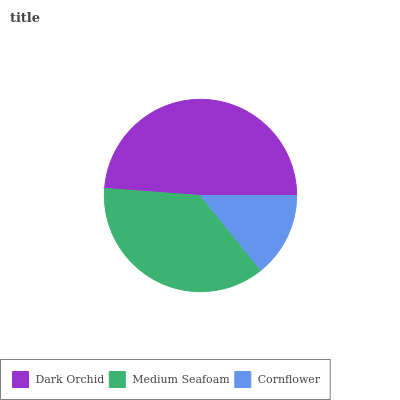Is Cornflower the minimum?
Answer yes or no. Yes. Is Dark Orchid the maximum?
Answer yes or no. Yes. Is Medium Seafoam the minimum?
Answer yes or no. No. Is Medium Seafoam the maximum?
Answer yes or no. No. Is Dark Orchid greater than Medium Seafoam?
Answer yes or no. Yes. Is Medium Seafoam less than Dark Orchid?
Answer yes or no. Yes. Is Medium Seafoam greater than Dark Orchid?
Answer yes or no. No. Is Dark Orchid less than Medium Seafoam?
Answer yes or no. No. Is Medium Seafoam the high median?
Answer yes or no. Yes. Is Medium Seafoam the low median?
Answer yes or no. Yes. Is Dark Orchid the high median?
Answer yes or no. No. Is Dark Orchid the low median?
Answer yes or no. No. 